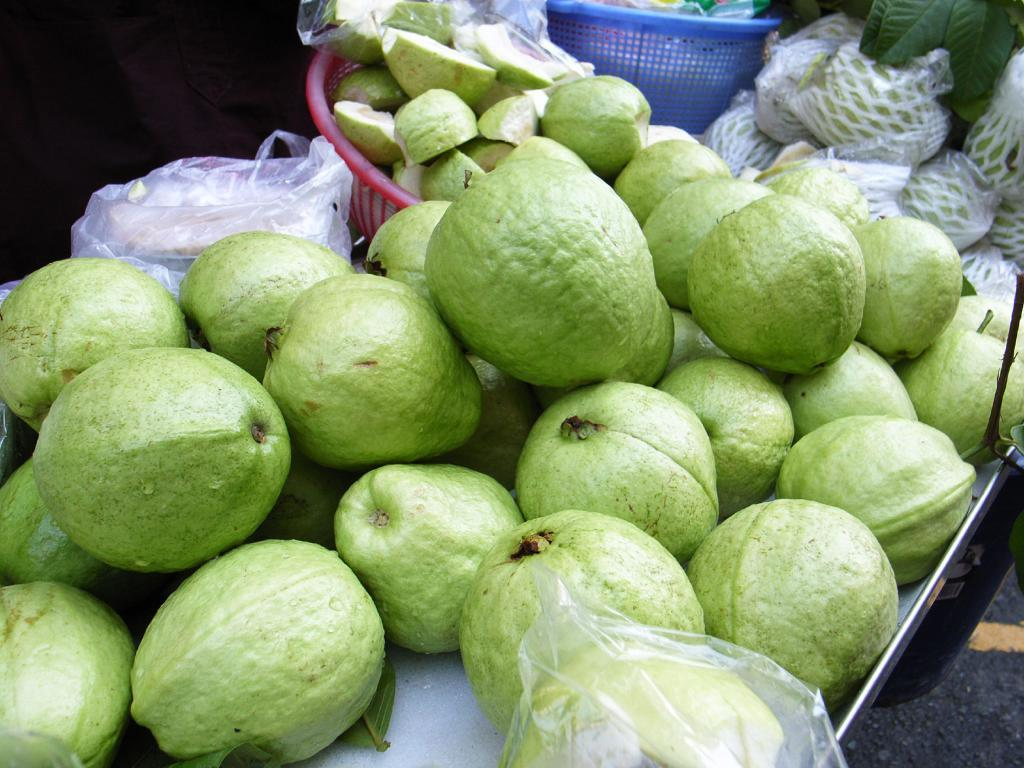What type of food can be seen in the image? There are fruits in the image. How are the fruits arranged or contained? The fruits are in baskets. What other item is present in the image? There is a tray in the image. Can you describe any other objects in the image? There are other unspecified objects in the image. How much money is being exchanged for the celery in the image? There is no celery or money present in the image; it only features fruits in baskets and a tray. What type of car is visible in the image? There is no car present in the image. 